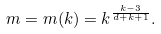<formula> <loc_0><loc_0><loc_500><loc_500>m = m ( k ) = k ^ { \frac { k - 3 } { d + k + 1 } } .</formula> 